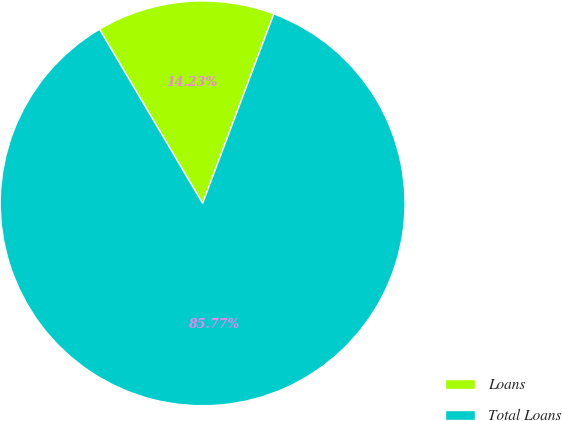<chart> <loc_0><loc_0><loc_500><loc_500><pie_chart><fcel>Loans<fcel>Total Loans<nl><fcel>14.23%<fcel>85.77%<nl></chart> 